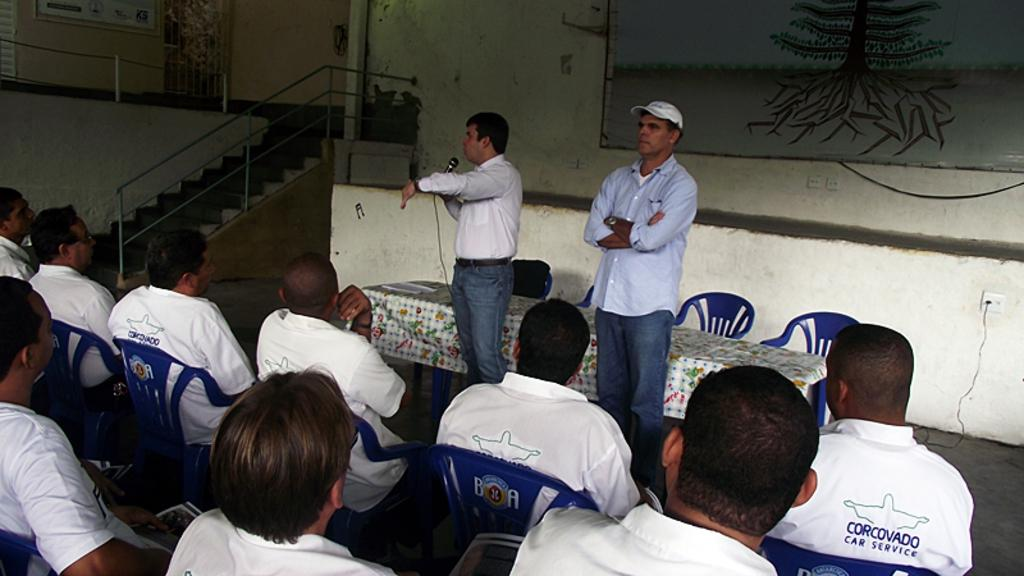<image>
Provide a brief description of the given image. The group of people who are sitting down are wearing shirts that say Corcovado Car Service 